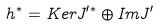<formula> <loc_0><loc_0><loc_500><loc_500>h ^ { * } = K e r J ^ { \prime * } \oplus I m J ^ { \prime }</formula> 